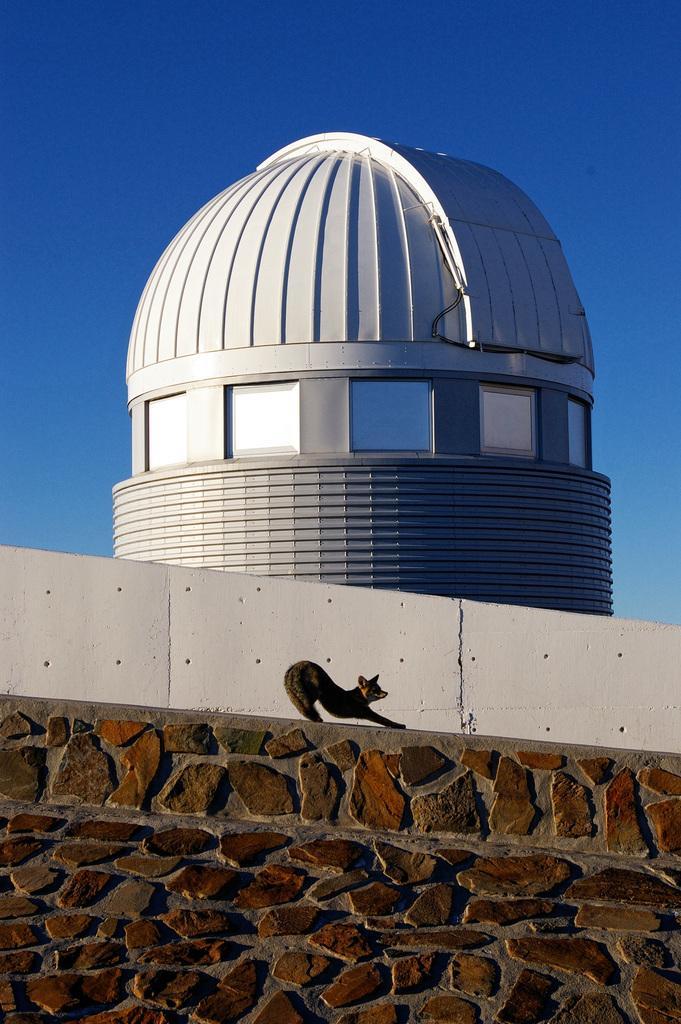How would you summarize this image in a sentence or two? In this image I see the architecture over here which is of white in color and I see the wall over here and I see an animal over here and I see the blue sky in the background. 